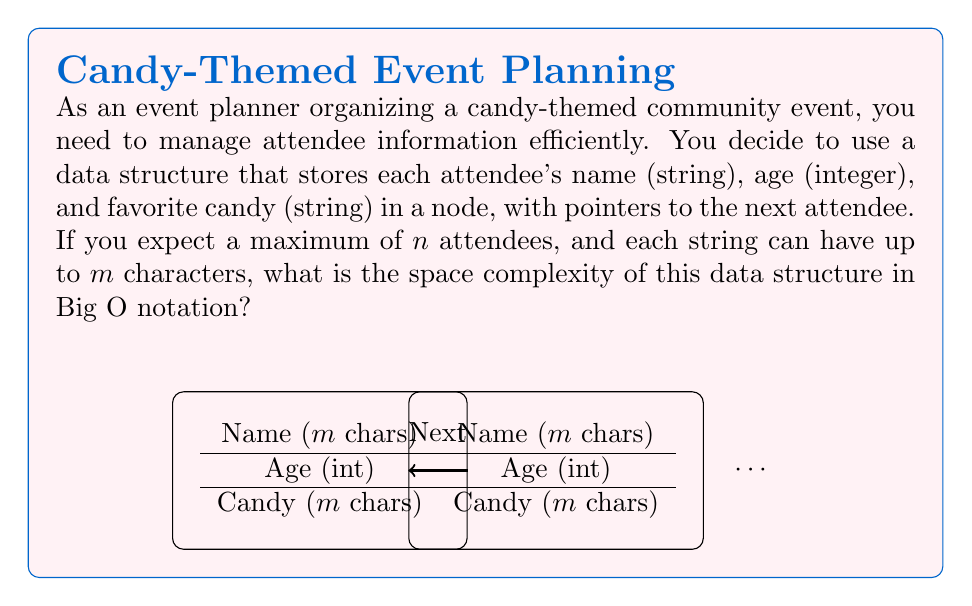Show me your answer to this math problem. Let's break down the space requirements for each component of the data structure:

1. Name (string): 
   - Each character typically requires 1 byte (8 bits) of storage.
   - With a maximum of $m$ characters, the space needed is $O(m)$.

2. Age (integer):
   - An integer typically requires 4 bytes (32 bits) of storage.
   - This is a constant amount of space, so it's $O(1)$.

3. Favorite candy (string):
   - Similar to the name, this requires $O(m)$ space.

4. Next pointer:
   - A pointer typically requires 8 bytes (64 bits) on modern systems.
   - This is also a constant amount of space, so it's $O(1)$.

For each attendee, the total space required is:
$$ O(m) + O(1) + O(m) + O(1) = O(2m + 2) = O(m) $$

Since we have $n$ attendees, the total space complexity for all attendees is:
$$ n \cdot O(m) = O(nm) $$

Therefore, the overall space complexity of the data structure is $O(nm)$.
Answer: $O(nm)$ 